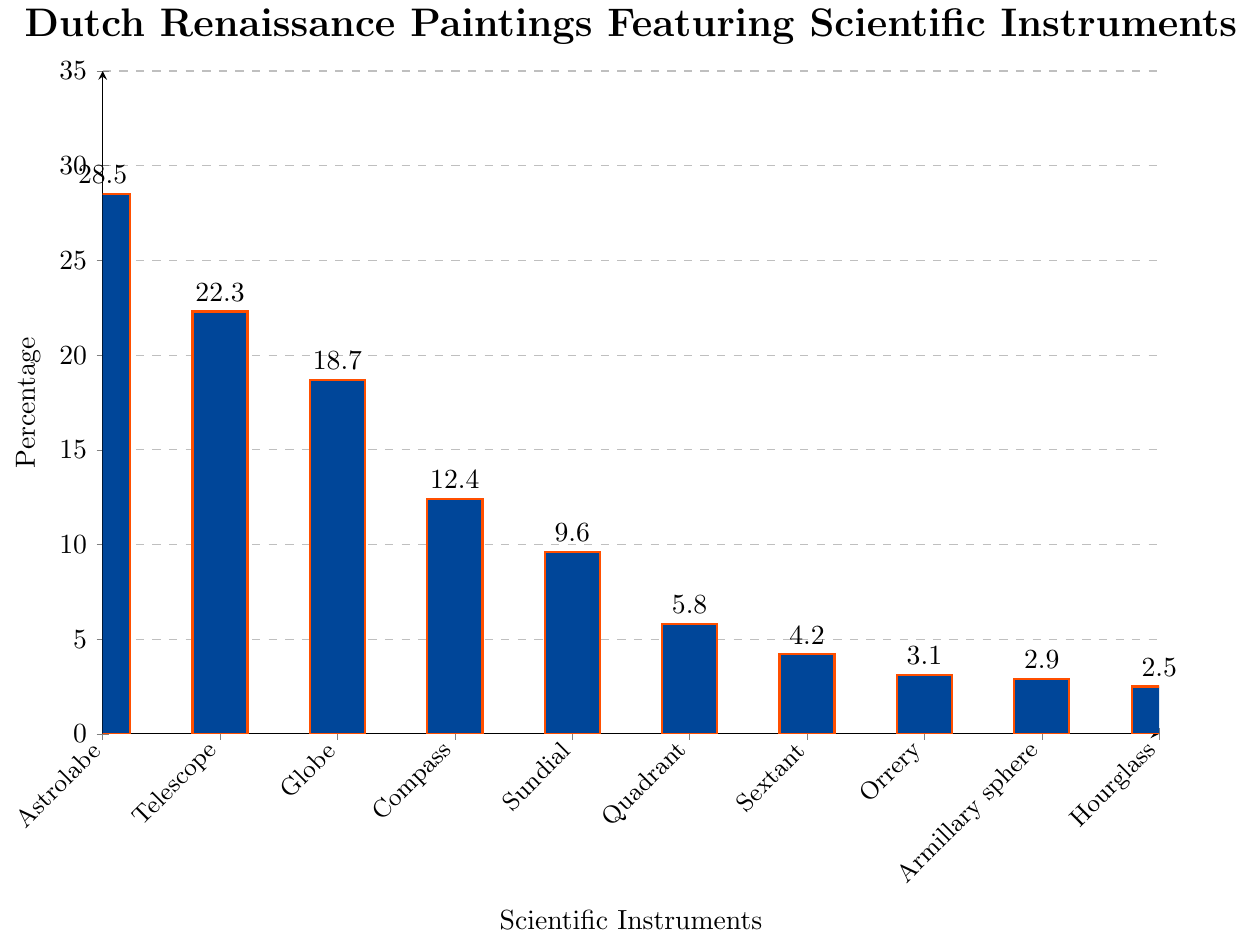What percentage of Dutch Renaissance paintings feature a Globe? Locate the bar labeled 'Globe' on the x-axis and read the percentage value listed at the top of the bar
Answer: 18.7% Which scientific instrument appears least frequently in Dutch Renaissance paintings? Compare the heights of all bars in the chart and identify the shortest one, which corresponds to the instrument with the lowest percentage value
Answer: Hourglass How much more frequent are Astrolabes compared to Sundials in Dutch Renaissance paintings? Find the percentage values for Astrolabe (28.5%) and Sundial (9.6%) and compute the difference: 28.5% - 9.6% = 18.9%
Answer: 18.9% Which instrument category has a percentage value closest to the average percentage of all instruments? Calculate the average percentage by adding all percentages and dividing by the number of instruments: (28.5 + 22.3 + 18.7 + 12.4 + 9.6 + 5.8 + 4.2 + 3.1 + 2.9 + 2.5) / 10 = 11.00%. Locate the bar closest to this value
Answer: Compass Compare the combined percentage of Astrolabe and Telescope against the combined percentage of Quadrant and Sextant Sum the percentages for Astrolabe and Telescope: 28.5 + 22.3 = 50.8%. Then sum the percentages for Quadrant and Sextant: 5.8 + 4.2 = 10%. Compare the two sums: 50.8% > 10%
Answer: The combined percentage of Astrolabe and Telescope is greater Identify any scientific instruments that have a percentage below 5% in Dutch Renaissance paintings Check the percentage values for each instrument and list those with percentages below 5%: Sextant (4.2%), Orrery (3.1%), Armillary sphere (2.9%), Hourglass (2.5%)
Answer: Sextant, Orrery, Armillary sphere, Hourglass What is the total percentage for the top three most frequently depicted scientific instruments? Add the percentages for the top three instruments: Astrolabe (28.5%), Telescope (22.3%), and Globe (18.7%): 28.5 + 22.3 + 18.7 = 69.5%
Answer: 69.5% How does the percentage of paintings featuring Compasses compare to those featuring Globes? Compare the percentage values of Compass (12.4%) and Globe (18.7%): Compass's percentage is lower
Answer: Compass appears less frequently than Globe What is the sum of the percentages for all instruments that are depicted less frequently than 10%? Sum the percentages for Quadrant (5.8%), Sextant (4.2%), Orrery (3.1%), Armillary sphere (2.9%), Hourglass (2.5%): 5.8 + 4.2 + 3.1 + 2.9 + 2.5 = 18.5%
Answer: 18.5% List the instruments in ascending order of their depiction frequency in Dutch Renaissance paintings Arrange the instruments by their percentage values from lowest to highest: Hourglass (2.5%), Armillary sphere (2.9%), Orrery (3.1%), Sextant (4.2%), Quadrant (5.8%), Sundial (9.6%), Compass (12.4%), Globe (18.7%), Telescope (22.3%), Astrolabe (28.5%)
Answer: Hourglass, Armillary sphere, Orrery, Sextant, Quadrant, Sundial, Compass, Globe, Telescope, Astrolabe 